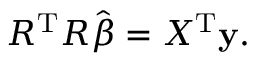<formula> <loc_0><loc_0><loc_500><loc_500>R ^ { T } R { \hat { \beta } } = X ^ { T } y .</formula> 